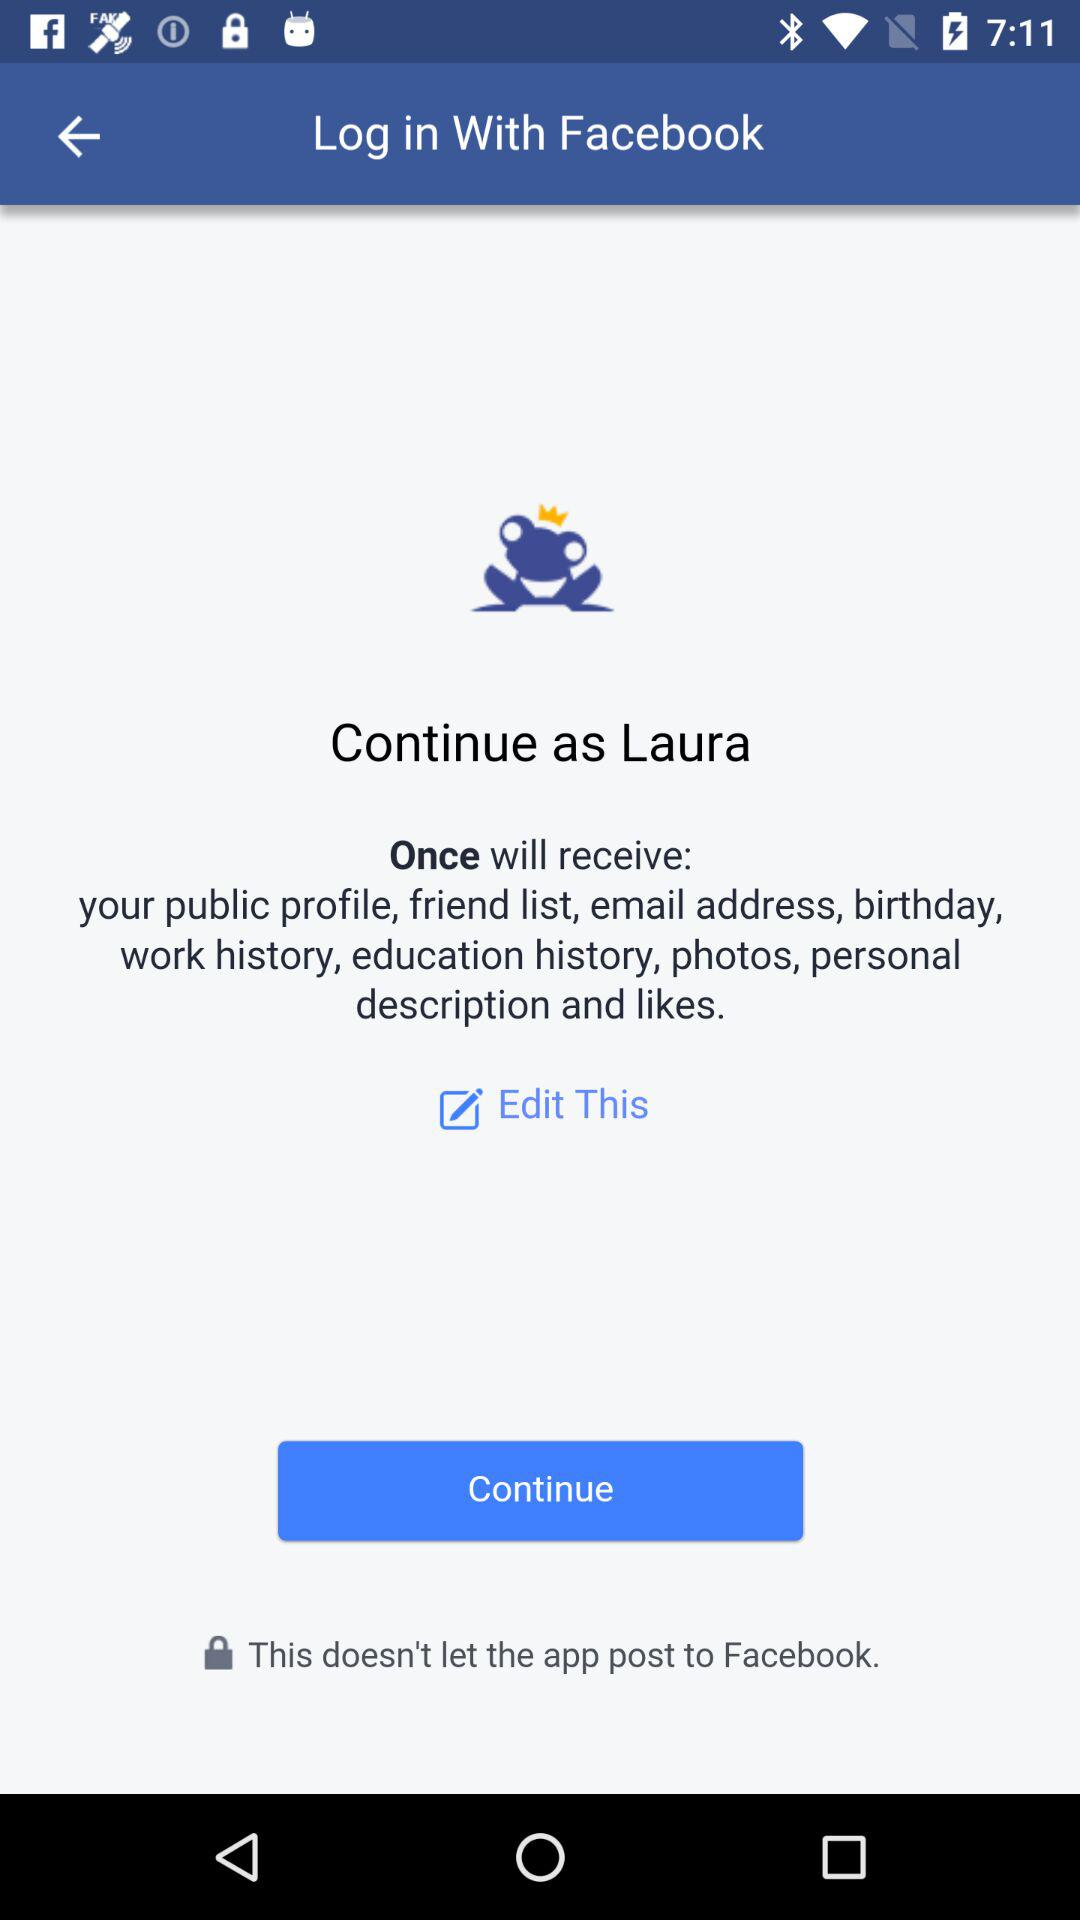Who will receive the public profile, email address, friend list, birthday,work history, education history, personal description and likes? The public profile, email address, friend list, birthday,work history, education history, personal description and likes will be received by "Once". 